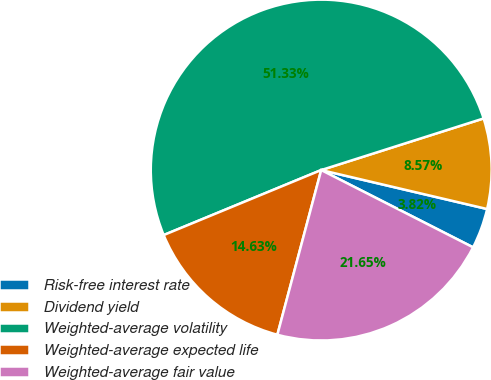Convert chart. <chart><loc_0><loc_0><loc_500><loc_500><pie_chart><fcel>Risk-free interest rate<fcel>Dividend yield<fcel>Weighted-average volatility<fcel>Weighted-average expected life<fcel>Weighted-average fair value<nl><fcel>3.82%<fcel>8.57%<fcel>51.33%<fcel>14.63%<fcel>21.65%<nl></chart> 